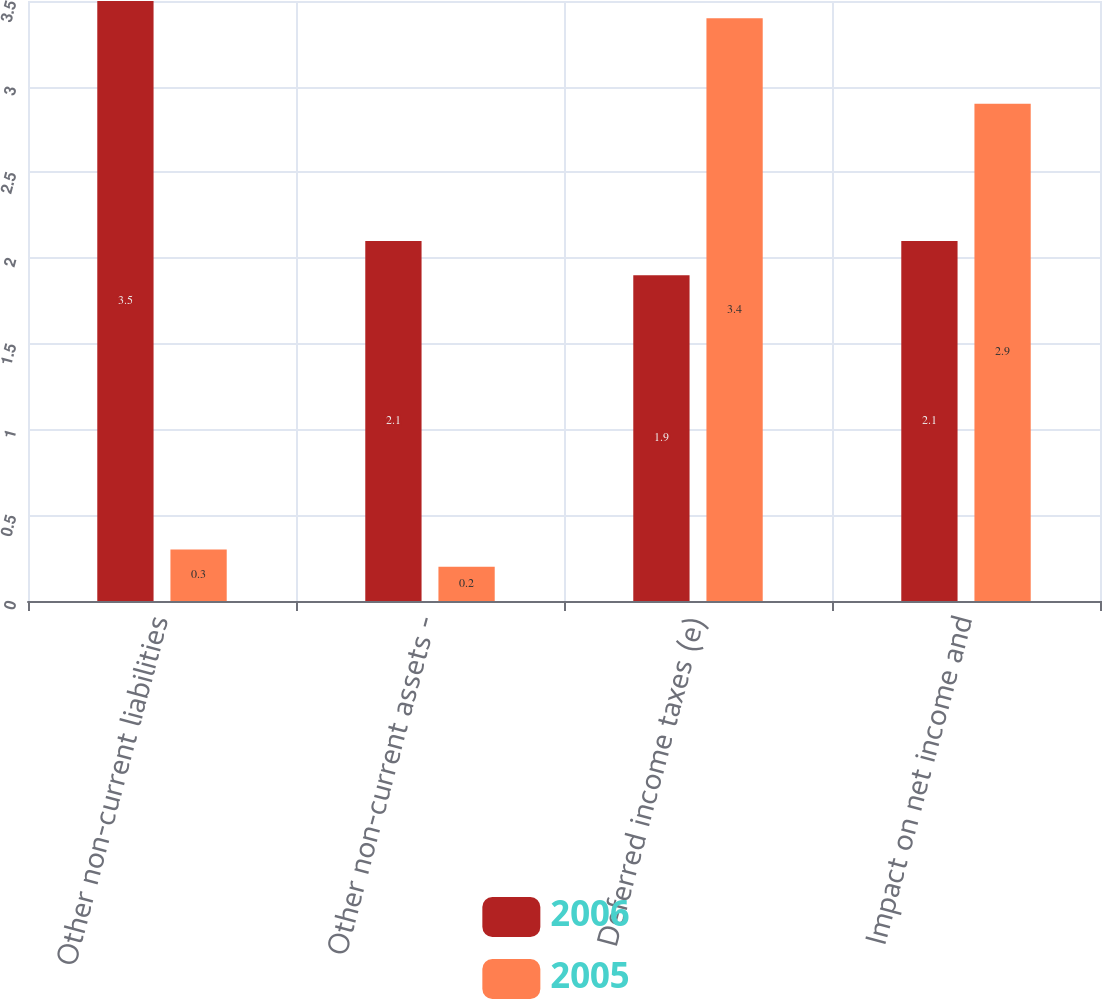Convert chart to OTSL. <chart><loc_0><loc_0><loc_500><loc_500><stacked_bar_chart><ecel><fcel>Other non-current liabilities<fcel>Other non-current assets -<fcel>Deferred income taxes (e)<fcel>Impact on net income and<nl><fcel>2006<fcel>3.5<fcel>2.1<fcel>1.9<fcel>2.1<nl><fcel>2005<fcel>0.3<fcel>0.2<fcel>3.4<fcel>2.9<nl></chart> 